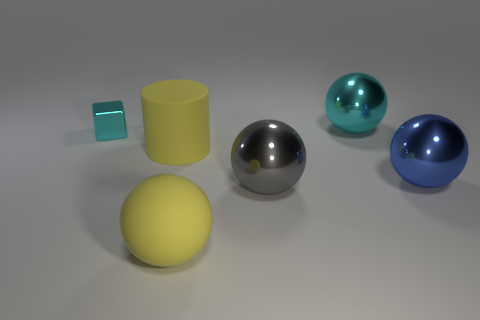Can you describe the lighting and shadows in the scene? The image is lit from above, casting soft shadows directly underneath the objects. The shadows are consistent with an overhead light source. The reflective surfaces, particularly of the metallic spheres, have bright highlight spots where the light source is most directly reflected, while the matte yellow sphere and the cylinder have more diffused and soft lighting with less pronounced highlights. 